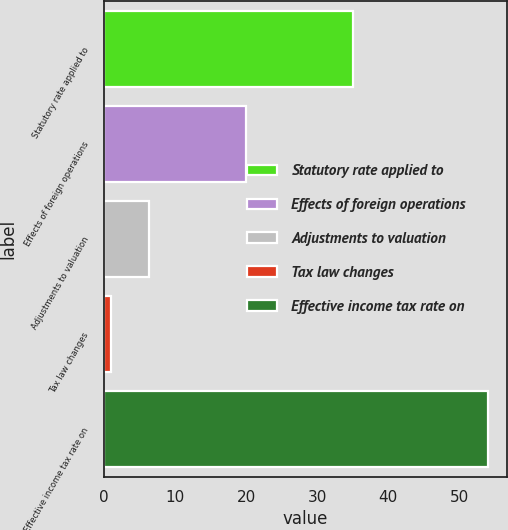Convert chart. <chart><loc_0><loc_0><loc_500><loc_500><bar_chart><fcel>Statutory rate applied to<fcel>Effects of foreign operations<fcel>Adjustments to valuation<fcel>Tax law changes<fcel>Effective income tax rate on<nl><fcel>35<fcel>20<fcel>6.3<fcel>1<fcel>54<nl></chart> 